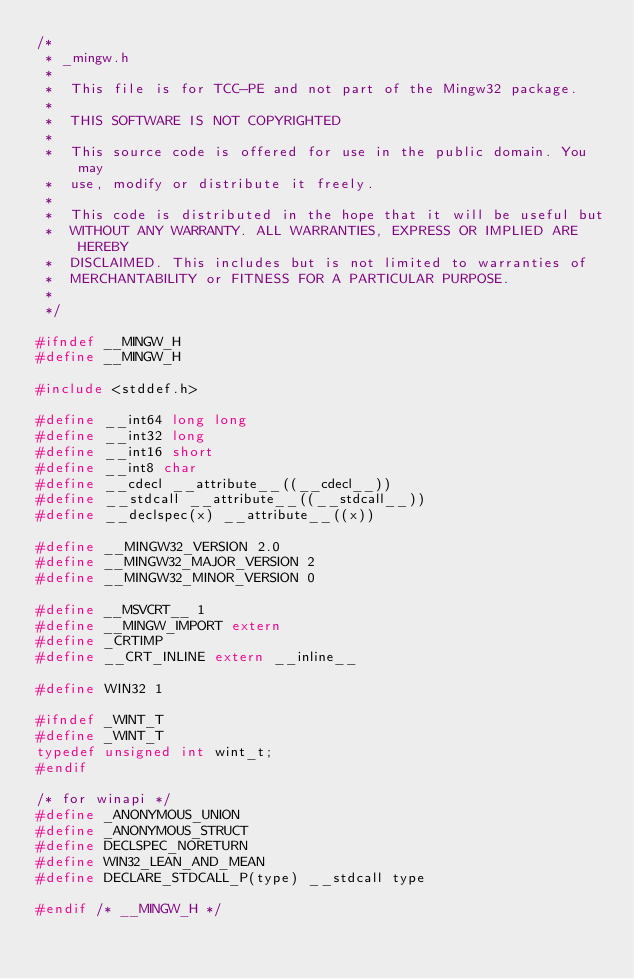<code> <loc_0><loc_0><loc_500><loc_500><_C_>/*
 * _mingw.h
 *
 *  This file is for TCC-PE and not part of the Mingw32 package.
 *
 *  THIS SOFTWARE IS NOT COPYRIGHTED
 *
 *  This source code is offered for use in the public domain. You may
 *  use, modify or distribute it freely.
 *
 *  This code is distributed in the hope that it will be useful but
 *  WITHOUT ANY WARRANTY. ALL WARRANTIES, EXPRESS OR IMPLIED ARE HEREBY
 *  DISCLAIMED. This includes but is not limited to warranties of
 *  MERCHANTABILITY or FITNESS FOR A PARTICULAR PURPOSE.
 *
 */

#ifndef __MINGW_H
#define __MINGW_H

#include <stddef.h>

#define __int64 long long
#define __int32 long
#define __int16 short
#define __int8 char
#define __cdecl __attribute__((__cdecl__))
#define __stdcall __attribute__((__stdcall__))
#define __declspec(x) __attribute__((x))

#define __MINGW32_VERSION 2.0
#define __MINGW32_MAJOR_VERSION 2
#define __MINGW32_MINOR_VERSION 0

#define __MSVCRT__ 1
#define __MINGW_IMPORT extern
#define _CRTIMP
#define __CRT_INLINE extern __inline__

#define WIN32 1

#ifndef _WINT_T
#define _WINT_T
typedef unsigned int wint_t;
#endif

/* for winapi */
#define _ANONYMOUS_UNION
#define _ANONYMOUS_STRUCT
#define DECLSPEC_NORETURN
#define WIN32_LEAN_AND_MEAN
#define DECLARE_STDCALL_P(type) __stdcall type

#endif /* __MINGW_H */
</code> 